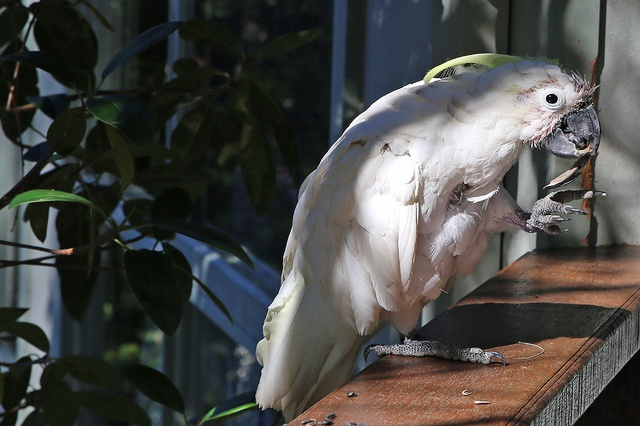Describe the objects in this image and their specific colors. I can see a bird in black, gray, lightgray, and darkgray tones in this image. 